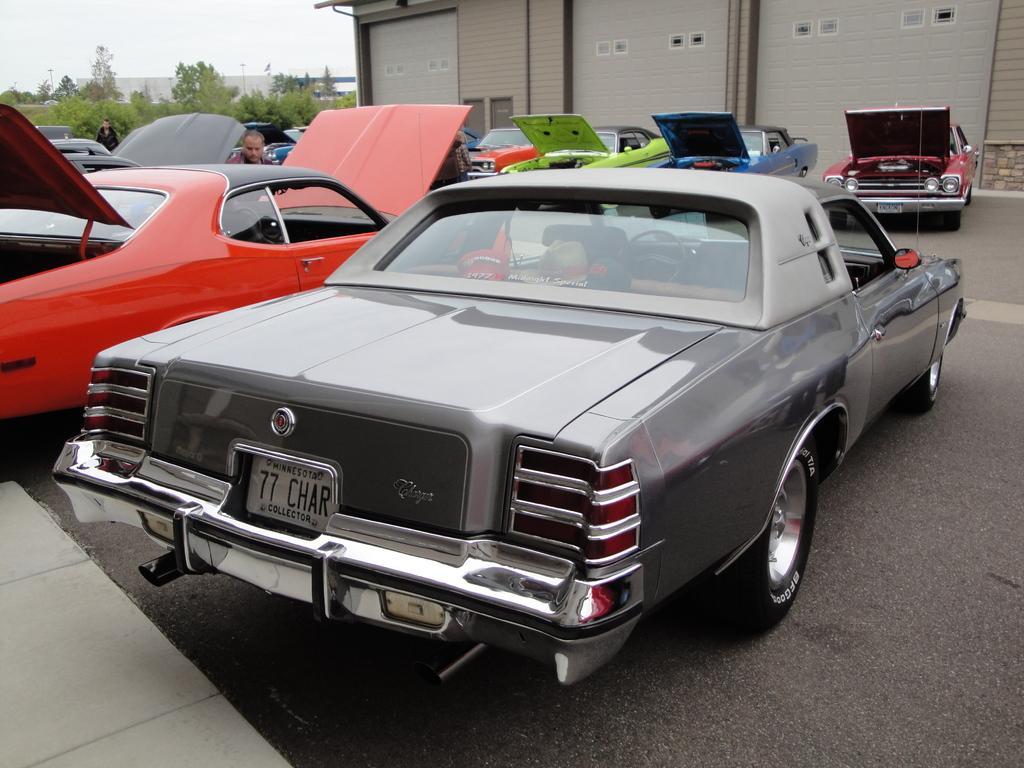Could you give a brief overview of what you see in this image? In this picture there are cars in the center and background area of the image and there are trees on the left side of the image and there is a building at the top side of the image. 